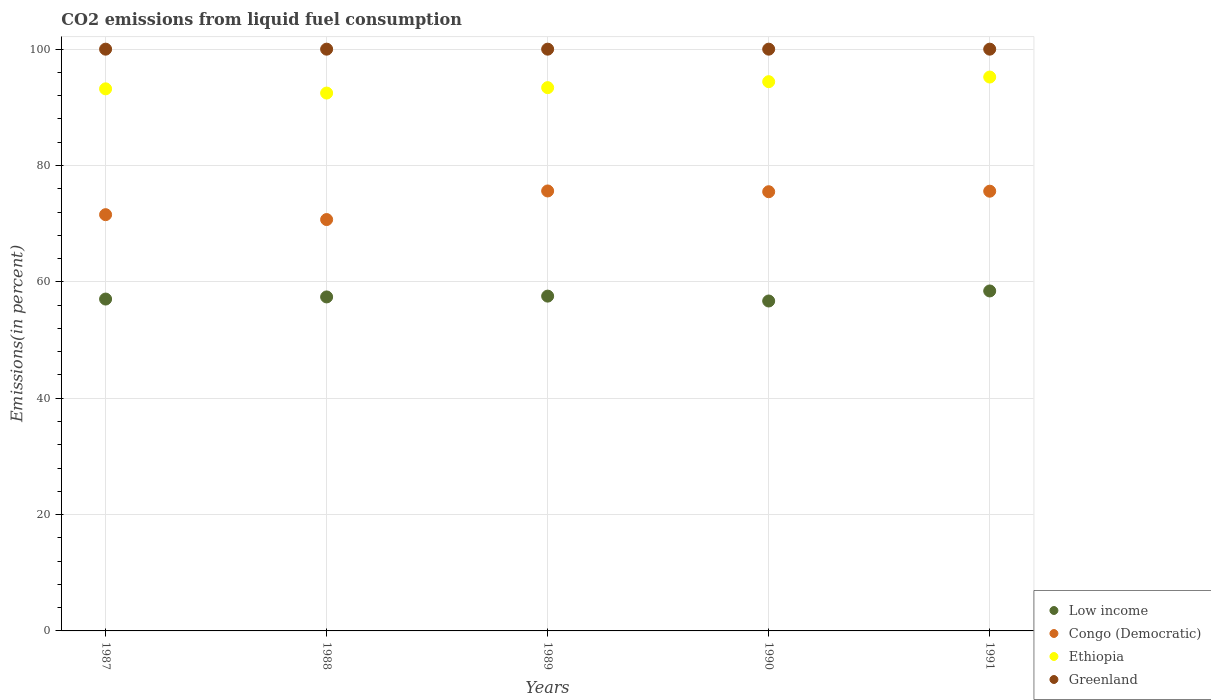What is the total CO2 emitted in Low income in 1990?
Your response must be concise. 56.71. Across all years, what is the maximum total CO2 emitted in Congo (Democratic)?
Ensure brevity in your answer.  75.63. Across all years, what is the minimum total CO2 emitted in Low income?
Your response must be concise. 56.71. In which year was the total CO2 emitted in Greenland maximum?
Ensure brevity in your answer.  1987. What is the total total CO2 emitted in Greenland in the graph?
Provide a succinct answer. 500. What is the difference between the total CO2 emitted in Congo (Democratic) in 1991 and the total CO2 emitted in Low income in 1987?
Your answer should be compact. 18.54. What is the average total CO2 emitted in Congo (Democratic) per year?
Your answer should be compact. 73.79. In the year 1991, what is the difference between the total CO2 emitted in Congo (Democratic) and total CO2 emitted in Greenland?
Provide a succinct answer. -24.41. In how many years, is the total CO2 emitted in Greenland greater than 24 %?
Provide a short and direct response. 5. What is the ratio of the total CO2 emitted in Congo (Democratic) in 1990 to that in 1991?
Keep it short and to the point. 1. What is the difference between the highest and the second highest total CO2 emitted in Low income?
Give a very brief answer. 0.89. What is the difference between the highest and the lowest total CO2 emitted in Low income?
Give a very brief answer. 1.73. In how many years, is the total CO2 emitted in Greenland greater than the average total CO2 emitted in Greenland taken over all years?
Your answer should be very brief. 0. Is it the case that in every year, the sum of the total CO2 emitted in Congo (Democratic) and total CO2 emitted in Ethiopia  is greater than the sum of total CO2 emitted in Low income and total CO2 emitted in Greenland?
Your answer should be compact. No. Is the total CO2 emitted in Greenland strictly greater than the total CO2 emitted in Congo (Democratic) over the years?
Provide a short and direct response. Yes. Is the total CO2 emitted in Congo (Democratic) strictly less than the total CO2 emitted in Ethiopia over the years?
Provide a succinct answer. Yes. How many years are there in the graph?
Offer a very short reply. 5. What is the difference between two consecutive major ticks on the Y-axis?
Make the answer very short. 20. Are the values on the major ticks of Y-axis written in scientific E-notation?
Offer a very short reply. No. Does the graph contain any zero values?
Make the answer very short. No. How many legend labels are there?
Make the answer very short. 4. How are the legend labels stacked?
Make the answer very short. Vertical. What is the title of the graph?
Provide a succinct answer. CO2 emissions from liquid fuel consumption. What is the label or title of the Y-axis?
Offer a very short reply. Emissions(in percent). What is the Emissions(in percent) of Low income in 1987?
Your answer should be very brief. 57.05. What is the Emissions(in percent) of Congo (Democratic) in 1987?
Provide a short and direct response. 71.55. What is the Emissions(in percent) in Ethiopia in 1987?
Offer a terse response. 93.18. What is the Emissions(in percent) in Greenland in 1987?
Give a very brief answer. 100. What is the Emissions(in percent) of Low income in 1988?
Give a very brief answer. 57.41. What is the Emissions(in percent) in Congo (Democratic) in 1988?
Offer a very short reply. 70.71. What is the Emissions(in percent) in Ethiopia in 1988?
Provide a short and direct response. 92.46. What is the Emissions(in percent) of Greenland in 1988?
Make the answer very short. 100. What is the Emissions(in percent) in Low income in 1989?
Offer a very short reply. 57.55. What is the Emissions(in percent) in Congo (Democratic) in 1989?
Your answer should be compact. 75.63. What is the Emissions(in percent) of Ethiopia in 1989?
Keep it short and to the point. 93.39. What is the Emissions(in percent) of Low income in 1990?
Keep it short and to the point. 56.71. What is the Emissions(in percent) in Congo (Democratic) in 1990?
Your answer should be compact. 75.5. What is the Emissions(in percent) in Ethiopia in 1990?
Ensure brevity in your answer.  94.41. What is the Emissions(in percent) of Low income in 1991?
Ensure brevity in your answer.  58.44. What is the Emissions(in percent) in Congo (Democratic) in 1991?
Make the answer very short. 75.59. What is the Emissions(in percent) of Ethiopia in 1991?
Your answer should be very brief. 95.21. Across all years, what is the maximum Emissions(in percent) of Low income?
Provide a succinct answer. 58.44. Across all years, what is the maximum Emissions(in percent) of Congo (Democratic)?
Your response must be concise. 75.63. Across all years, what is the maximum Emissions(in percent) in Ethiopia?
Your answer should be very brief. 95.21. Across all years, what is the minimum Emissions(in percent) in Low income?
Keep it short and to the point. 56.71. Across all years, what is the minimum Emissions(in percent) in Congo (Democratic)?
Your answer should be compact. 70.71. Across all years, what is the minimum Emissions(in percent) of Ethiopia?
Give a very brief answer. 92.46. What is the total Emissions(in percent) of Low income in the graph?
Make the answer very short. 287.16. What is the total Emissions(in percent) in Congo (Democratic) in the graph?
Provide a succinct answer. 368.97. What is the total Emissions(in percent) of Ethiopia in the graph?
Offer a very short reply. 468.64. What is the total Emissions(in percent) of Greenland in the graph?
Give a very brief answer. 500. What is the difference between the Emissions(in percent) of Low income in 1987 and that in 1988?
Provide a short and direct response. -0.37. What is the difference between the Emissions(in percent) of Congo (Democratic) in 1987 and that in 1988?
Offer a very short reply. 0.84. What is the difference between the Emissions(in percent) in Ethiopia in 1987 and that in 1988?
Give a very brief answer. 0.73. What is the difference between the Emissions(in percent) in Greenland in 1987 and that in 1988?
Offer a terse response. 0. What is the difference between the Emissions(in percent) in Low income in 1987 and that in 1989?
Offer a terse response. -0.51. What is the difference between the Emissions(in percent) in Congo (Democratic) in 1987 and that in 1989?
Offer a very short reply. -4.08. What is the difference between the Emissions(in percent) of Ethiopia in 1987 and that in 1989?
Your response must be concise. -0.2. What is the difference between the Emissions(in percent) of Greenland in 1987 and that in 1989?
Provide a succinct answer. 0. What is the difference between the Emissions(in percent) in Low income in 1987 and that in 1990?
Your answer should be very brief. 0.33. What is the difference between the Emissions(in percent) in Congo (Democratic) in 1987 and that in 1990?
Your answer should be compact. -3.94. What is the difference between the Emissions(in percent) of Ethiopia in 1987 and that in 1990?
Give a very brief answer. -1.23. What is the difference between the Emissions(in percent) in Low income in 1987 and that in 1991?
Keep it short and to the point. -1.39. What is the difference between the Emissions(in percent) in Congo (Democratic) in 1987 and that in 1991?
Your answer should be compact. -4.04. What is the difference between the Emissions(in percent) of Ethiopia in 1987 and that in 1991?
Provide a succinct answer. -2.03. What is the difference between the Emissions(in percent) of Greenland in 1987 and that in 1991?
Your answer should be very brief. 0. What is the difference between the Emissions(in percent) of Low income in 1988 and that in 1989?
Your response must be concise. -0.14. What is the difference between the Emissions(in percent) of Congo (Democratic) in 1988 and that in 1989?
Keep it short and to the point. -4.91. What is the difference between the Emissions(in percent) in Ethiopia in 1988 and that in 1989?
Make the answer very short. -0.93. What is the difference between the Emissions(in percent) in Low income in 1988 and that in 1990?
Your answer should be compact. 0.7. What is the difference between the Emissions(in percent) in Congo (Democratic) in 1988 and that in 1990?
Make the answer very short. -4.78. What is the difference between the Emissions(in percent) of Ethiopia in 1988 and that in 1990?
Make the answer very short. -1.96. What is the difference between the Emissions(in percent) of Greenland in 1988 and that in 1990?
Offer a terse response. 0. What is the difference between the Emissions(in percent) in Low income in 1988 and that in 1991?
Your answer should be very brief. -1.03. What is the difference between the Emissions(in percent) of Congo (Democratic) in 1988 and that in 1991?
Your answer should be compact. -4.87. What is the difference between the Emissions(in percent) in Ethiopia in 1988 and that in 1991?
Offer a very short reply. -2.75. What is the difference between the Emissions(in percent) of Greenland in 1988 and that in 1991?
Offer a very short reply. 0. What is the difference between the Emissions(in percent) of Low income in 1989 and that in 1990?
Provide a short and direct response. 0.84. What is the difference between the Emissions(in percent) in Congo (Democratic) in 1989 and that in 1990?
Make the answer very short. 0.13. What is the difference between the Emissions(in percent) of Ethiopia in 1989 and that in 1990?
Your response must be concise. -1.03. What is the difference between the Emissions(in percent) in Greenland in 1989 and that in 1990?
Your response must be concise. 0. What is the difference between the Emissions(in percent) of Low income in 1989 and that in 1991?
Give a very brief answer. -0.89. What is the difference between the Emissions(in percent) in Congo (Democratic) in 1989 and that in 1991?
Your answer should be very brief. 0.04. What is the difference between the Emissions(in percent) in Ethiopia in 1989 and that in 1991?
Offer a very short reply. -1.82. What is the difference between the Emissions(in percent) of Greenland in 1989 and that in 1991?
Your answer should be very brief. 0. What is the difference between the Emissions(in percent) in Low income in 1990 and that in 1991?
Offer a very short reply. -1.73. What is the difference between the Emissions(in percent) in Congo (Democratic) in 1990 and that in 1991?
Your answer should be very brief. -0.09. What is the difference between the Emissions(in percent) in Ethiopia in 1990 and that in 1991?
Make the answer very short. -0.8. What is the difference between the Emissions(in percent) in Greenland in 1990 and that in 1991?
Make the answer very short. 0. What is the difference between the Emissions(in percent) in Low income in 1987 and the Emissions(in percent) in Congo (Democratic) in 1988?
Your answer should be very brief. -13.67. What is the difference between the Emissions(in percent) of Low income in 1987 and the Emissions(in percent) of Ethiopia in 1988?
Your answer should be very brief. -35.41. What is the difference between the Emissions(in percent) of Low income in 1987 and the Emissions(in percent) of Greenland in 1988?
Your answer should be compact. -42.95. What is the difference between the Emissions(in percent) of Congo (Democratic) in 1987 and the Emissions(in percent) of Ethiopia in 1988?
Your answer should be very brief. -20.9. What is the difference between the Emissions(in percent) of Congo (Democratic) in 1987 and the Emissions(in percent) of Greenland in 1988?
Ensure brevity in your answer.  -28.45. What is the difference between the Emissions(in percent) in Ethiopia in 1987 and the Emissions(in percent) in Greenland in 1988?
Offer a very short reply. -6.82. What is the difference between the Emissions(in percent) in Low income in 1987 and the Emissions(in percent) in Congo (Democratic) in 1989?
Keep it short and to the point. -18.58. What is the difference between the Emissions(in percent) in Low income in 1987 and the Emissions(in percent) in Ethiopia in 1989?
Your answer should be compact. -36.34. What is the difference between the Emissions(in percent) of Low income in 1987 and the Emissions(in percent) of Greenland in 1989?
Keep it short and to the point. -42.95. What is the difference between the Emissions(in percent) in Congo (Democratic) in 1987 and the Emissions(in percent) in Ethiopia in 1989?
Keep it short and to the point. -21.83. What is the difference between the Emissions(in percent) in Congo (Democratic) in 1987 and the Emissions(in percent) in Greenland in 1989?
Your response must be concise. -28.45. What is the difference between the Emissions(in percent) in Ethiopia in 1987 and the Emissions(in percent) in Greenland in 1989?
Offer a very short reply. -6.82. What is the difference between the Emissions(in percent) in Low income in 1987 and the Emissions(in percent) in Congo (Democratic) in 1990?
Make the answer very short. -18.45. What is the difference between the Emissions(in percent) of Low income in 1987 and the Emissions(in percent) of Ethiopia in 1990?
Give a very brief answer. -37.37. What is the difference between the Emissions(in percent) of Low income in 1987 and the Emissions(in percent) of Greenland in 1990?
Your response must be concise. -42.95. What is the difference between the Emissions(in percent) of Congo (Democratic) in 1987 and the Emissions(in percent) of Ethiopia in 1990?
Your response must be concise. -22.86. What is the difference between the Emissions(in percent) of Congo (Democratic) in 1987 and the Emissions(in percent) of Greenland in 1990?
Your response must be concise. -28.45. What is the difference between the Emissions(in percent) of Ethiopia in 1987 and the Emissions(in percent) of Greenland in 1990?
Offer a terse response. -6.82. What is the difference between the Emissions(in percent) of Low income in 1987 and the Emissions(in percent) of Congo (Democratic) in 1991?
Keep it short and to the point. -18.54. What is the difference between the Emissions(in percent) of Low income in 1987 and the Emissions(in percent) of Ethiopia in 1991?
Provide a short and direct response. -38.16. What is the difference between the Emissions(in percent) of Low income in 1987 and the Emissions(in percent) of Greenland in 1991?
Offer a terse response. -42.95. What is the difference between the Emissions(in percent) in Congo (Democratic) in 1987 and the Emissions(in percent) in Ethiopia in 1991?
Ensure brevity in your answer.  -23.66. What is the difference between the Emissions(in percent) of Congo (Democratic) in 1987 and the Emissions(in percent) of Greenland in 1991?
Keep it short and to the point. -28.45. What is the difference between the Emissions(in percent) of Ethiopia in 1987 and the Emissions(in percent) of Greenland in 1991?
Offer a terse response. -6.82. What is the difference between the Emissions(in percent) in Low income in 1988 and the Emissions(in percent) in Congo (Democratic) in 1989?
Provide a succinct answer. -18.21. What is the difference between the Emissions(in percent) in Low income in 1988 and the Emissions(in percent) in Ethiopia in 1989?
Provide a succinct answer. -35.97. What is the difference between the Emissions(in percent) in Low income in 1988 and the Emissions(in percent) in Greenland in 1989?
Your response must be concise. -42.59. What is the difference between the Emissions(in percent) in Congo (Democratic) in 1988 and the Emissions(in percent) in Ethiopia in 1989?
Offer a terse response. -22.67. What is the difference between the Emissions(in percent) in Congo (Democratic) in 1988 and the Emissions(in percent) in Greenland in 1989?
Your answer should be compact. -29.29. What is the difference between the Emissions(in percent) in Ethiopia in 1988 and the Emissions(in percent) in Greenland in 1989?
Offer a very short reply. -7.54. What is the difference between the Emissions(in percent) in Low income in 1988 and the Emissions(in percent) in Congo (Democratic) in 1990?
Ensure brevity in your answer.  -18.08. What is the difference between the Emissions(in percent) in Low income in 1988 and the Emissions(in percent) in Ethiopia in 1990?
Keep it short and to the point. -37. What is the difference between the Emissions(in percent) of Low income in 1988 and the Emissions(in percent) of Greenland in 1990?
Offer a terse response. -42.59. What is the difference between the Emissions(in percent) of Congo (Democratic) in 1988 and the Emissions(in percent) of Ethiopia in 1990?
Keep it short and to the point. -23.7. What is the difference between the Emissions(in percent) of Congo (Democratic) in 1988 and the Emissions(in percent) of Greenland in 1990?
Keep it short and to the point. -29.29. What is the difference between the Emissions(in percent) of Ethiopia in 1988 and the Emissions(in percent) of Greenland in 1990?
Give a very brief answer. -7.54. What is the difference between the Emissions(in percent) of Low income in 1988 and the Emissions(in percent) of Congo (Democratic) in 1991?
Your answer should be very brief. -18.17. What is the difference between the Emissions(in percent) in Low income in 1988 and the Emissions(in percent) in Ethiopia in 1991?
Provide a succinct answer. -37.8. What is the difference between the Emissions(in percent) of Low income in 1988 and the Emissions(in percent) of Greenland in 1991?
Offer a very short reply. -42.59. What is the difference between the Emissions(in percent) of Congo (Democratic) in 1988 and the Emissions(in percent) of Ethiopia in 1991?
Keep it short and to the point. -24.5. What is the difference between the Emissions(in percent) of Congo (Democratic) in 1988 and the Emissions(in percent) of Greenland in 1991?
Your answer should be compact. -29.29. What is the difference between the Emissions(in percent) of Ethiopia in 1988 and the Emissions(in percent) of Greenland in 1991?
Provide a succinct answer. -7.54. What is the difference between the Emissions(in percent) in Low income in 1989 and the Emissions(in percent) in Congo (Democratic) in 1990?
Your answer should be compact. -17.94. What is the difference between the Emissions(in percent) of Low income in 1989 and the Emissions(in percent) of Ethiopia in 1990?
Provide a short and direct response. -36.86. What is the difference between the Emissions(in percent) of Low income in 1989 and the Emissions(in percent) of Greenland in 1990?
Keep it short and to the point. -42.45. What is the difference between the Emissions(in percent) of Congo (Democratic) in 1989 and the Emissions(in percent) of Ethiopia in 1990?
Your answer should be very brief. -18.78. What is the difference between the Emissions(in percent) in Congo (Democratic) in 1989 and the Emissions(in percent) in Greenland in 1990?
Your answer should be compact. -24.37. What is the difference between the Emissions(in percent) in Ethiopia in 1989 and the Emissions(in percent) in Greenland in 1990?
Ensure brevity in your answer.  -6.61. What is the difference between the Emissions(in percent) of Low income in 1989 and the Emissions(in percent) of Congo (Democratic) in 1991?
Provide a succinct answer. -18.04. What is the difference between the Emissions(in percent) in Low income in 1989 and the Emissions(in percent) in Ethiopia in 1991?
Make the answer very short. -37.66. What is the difference between the Emissions(in percent) in Low income in 1989 and the Emissions(in percent) in Greenland in 1991?
Make the answer very short. -42.45. What is the difference between the Emissions(in percent) in Congo (Democratic) in 1989 and the Emissions(in percent) in Ethiopia in 1991?
Ensure brevity in your answer.  -19.58. What is the difference between the Emissions(in percent) of Congo (Democratic) in 1989 and the Emissions(in percent) of Greenland in 1991?
Provide a short and direct response. -24.37. What is the difference between the Emissions(in percent) of Ethiopia in 1989 and the Emissions(in percent) of Greenland in 1991?
Provide a short and direct response. -6.61. What is the difference between the Emissions(in percent) in Low income in 1990 and the Emissions(in percent) in Congo (Democratic) in 1991?
Keep it short and to the point. -18.87. What is the difference between the Emissions(in percent) of Low income in 1990 and the Emissions(in percent) of Ethiopia in 1991?
Offer a terse response. -38.5. What is the difference between the Emissions(in percent) in Low income in 1990 and the Emissions(in percent) in Greenland in 1991?
Give a very brief answer. -43.29. What is the difference between the Emissions(in percent) of Congo (Democratic) in 1990 and the Emissions(in percent) of Ethiopia in 1991?
Make the answer very short. -19.71. What is the difference between the Emissions(in percent) in Congo (Democratic) in 1990 and the Emissions(in percent) in Greenland in 1991?
Make the answer very short. -24.5. What is the difference between the Emissions(in percent) in Ethiopia in 1990 and the Emissions(in percent) in Greenland in 1991?
Give a very brief answer. -5.59. What is the average Emissions(in percent) of Low income per year?
Give a very brief answer. 57.43. What is the average Emissions(in percent) of Congo (Democratic) per year?
Offer a terse response. 73.79. What is the average Emissions(in percent) of Ethiopia per year?
Give a very brief answer. 93.73. What is the average Emissions(in percent) in Greenland per year?
Your answer should be very brief. 100. In the year 1987, what is the difference between the Emissions(in percent) of Low income and Emissions(in percent) of Congo (Democratic)?
Provide a short and direct response. -14.51. In the year 1987, what is the difference between the Emissions(in percent) of Low income and Emissions(in percent) of Ethiopia?
Your answer should be compact. -36.14. In the year 1987, what is the difference between the Emissions(in percent) in Low income and Emissions(in percent) in Greenland?
Your answer should be very brief. -42.95. In the year 1987, what is the difference between the Emissions(in percent) of Congo (Democratic) and Emissions(in percent) of Ethiopia?
Keep it short and to the point. -21.63. In the year 1987, what is the difference between the Emissions(in percent) in Congo (Democratic) and Emissions(in percent) in Greenland?
Give a very brief answer. -28.45. In the year 1987, what is the difference between the Emissions(in percent) of Ethiopia and Emissions(in percent) of Greenland?
Your response must be concise. -6.82. In the year 1988, what is the difference between the Emissions(in percent) of Low income and Emissions(in percent) of Ethiopia?
Provide a succinct answer. -35.04. In the year 1988, what is the difference between the Emissions(in percent) of Low income and Emissions(in percent) of Greenland?
Provide a succinct answer. -42.59. In the year 1988, what is the difference between the Emissions(in percent) of Congo (Democratic) and Emissions(in percent) of Ethiopia?
Your answer should be compact. -21.74. In the year 1988, what is the difference between the Emissions(in percent) in Congo (Democratic) and Emissions(in percent) in Greenland?
Offer a terse response. -29.29. In the year 1988, what is the difference between the Emissions(in percent) in Ethiopia and Emissions(in percent) in Greenland?
Keep it short and to the point. -7.54. In the year 1989, what is the difference between the Emissions(in percent) of Low income and Emissions(in percent) of Congo (Democratic)?
Offer a terse response. -18.08. In the year 1989, what is the difference between the Emissions(in percent) of Low income and Emissions(in percent) of Ethiopia?
Offer a terse response. -35.83. In the year 1989, what is the difference between the Emissions(in percent) in Low income and Emissions(in percent) in Greenland?
Your answer should be compact. -42.45. In the year 1989, what is the difference between the Emissions(in percent) in Congo (Democratic) and Emissions(in percent) in Ethiopia?
Provide a short and direct response. -17.76. In the year 1989, what is the difference between the Emissions(in percent) in Congo (Democratic) and Emissions(in percent) in Greenland?
Offer a very short reply. -24.37. In the year 1989, what is the difference between the Emissions(in percent) in Ethiopia and Emissions(in percent) in Greenland?
Ensure brevity in your answer.  -6.61. In the year 1990, what is the difference between the Emissions(in percent) in Low income and Emissions(in percent) in Congo (Democratic)?
Provide a short and direct response. -18.78. In the year 1990, what is the difference between the Emissions(in percent) in Low income and Emissions(in percent) in Ethiopia?
Ensure brevity in your answer.  -37.7. In the year 1990, what is the difference between the Emissions(in percent) of Low income and Emissions(in percent) of Greenland?
Your answer should be compact. -43.29. In the year 1990, what is the difference between the Emissions(in percent) of Congo (Democratic) and Emissions(in percent) of Ethiopia?
Give a very brief answer. -18.92. In the year 1990, what is the difference between the Emissions(in percent) in Congo (Democratic) and Emissions(in percent) in Greenland?
Offer a terse response. -24.5. In the year 1990, what is the difference between the Emissions(in percent) of Ethiopia and Emissions(in percent) of Greenland?
Your response must be concise. -5.59. In the year 1991, what is the difference between the Emissions(in percent) of Low income and Emissions(in percent) of Congo (Democratic)?
Keep it short and to the point. -17.15. In the year 1991, what is the difference between the Emissions(in percent) in Low income and Emissions(in percent) in Ethiopia?
Your answer should be very brief. -36.77. In the year 1991, what is the difference between the Emissions(in percent) of Low income and Emissions(in percent) of Greenland?
Keep it short and to the point. -41.56. In the year 1991, what is the difference between the Emissions(in percent) in Congo (Democratic) and Emissions(in percent) in Ethiopia?
Provide a short and direct response. -19.62. In the year 1991, what is the difference between the Emissions(in percent) of Congo (Democratic) and Emissions(in percent) of Greenland?
Your response must be concise. -24.41. In the year 1991, what is the difference between the Emissions(in percent) in Ethiopia and Emissions(in percent) in Greenland?
Offer a terse response. -4.79. What is the ratio of the Emissions(in percent) of Congo (Democratic) in 1987 to that in 1988?
Keep it short and to the point. 1.01. What is the ratio of the Emissions(in percent) of Ethiopia in 1987 to that in 1988?
Provide a succinct answer. 1.01. What is the ratio of the Emissions(in percent) of Low income in 1987 to that in 1989?
Make the answer very short. 0.99. What is the ratio of the Emissions(in percent) in Congo (Democratic) in 1987 to that in 1989?
Provide a short and direct response. 0.95. What is the ratio of the Emissions(in percent) of Ethiopia in 1987 to that in 1989?
Provide a short and direct response. 1. What is the ratio of the Emissions(in percent) of Low income in 1987 to that in 1990?
Provide a short and direct response. 1.01. What is the ratio of the Emissions(in percent) in Congo (Democratic) in 1987 to that in 1990?
Provide a succinct answer. 0.95. What is the ratio of the Emissions(in percent) in Low income in 1987 to that in 1991?
Your response must be concise. 0.98. What is the ratio of the Emissions(in percent) of Congo (Democratic) in 1987 to that in 1991?
Your answer should be compact. 0.95. What is the ratio of the Emissions(in percent) in Ethiopia in 1987 to that in 1991?
Keep it short and to the point. 0.98. What is the ratio of the Emissions(in percent) of Greenland in 1987 to that in 1991?
Give a very brief answer. 1. What is the ratio of the Emissions(in percent) in Low income in 1988 to that in 1989?
Keep it short and to the point. 1. What is the ratio of the Emissions(in percent) in Congo (Democratic) in 1988 to that in 1989?
Your response must be concise. 0.94. What is the ratio of the Emissions(in percent) of Greenland in 1988 to that in 1989?
Provide a short and direct response. 1. What is the ratio of the Emissions(in percent) of Low income in 1988 to that in 1990?
Make the answer very short. 1.01. What is the ratio of the Emissions(in percent) of Congo (Democratic) in 1988 to that in 1990?
Your answer should be compact. 0.94. What is the ratio of the Emissions(in percent) in Ethiopia in 1988 to that in 1990?
Provide a succinct answer. 0.98. What is the ratio of the Emissions(in percent) of Low income in 1988 to that in 1991?
Make the answer very short. 0.98. What is the ratio of the Emissions(in percent) in Congo (Democratic) in 1988 to that in 1991?
Keep it short and to the point. 0.94. What is the ratio of the Emissions(in percent) in Ethiopia in 1988 to that in 1991?
Offer a very short reply. 0.97. What is the ratio of the Emissions(in percent) of Low income in 1989 to that in 1990?
Ensure brevity in your answer.  1.01. What is the ratio of the Emissions(in percent) of Congo (Democratic) in 1989 to that in 1990?
Your answer should be compact. 1. What is the ratio of the Emissions(in percent) in Ethiopia in 1989 to that in 1990?
Keep it short and to the point. 0.99. What is the ratio of the Emissions(in percent) of Greenland in 1989 to that in 1990?
Provide a short and direct response. 1. What is the ratio of the Emissions(in percent) in Ethiopia in 1989 to that in 1991?
Offer a very short reply. 0.98. What is the ratio of the Emissions(in percent) in Low income in 1990 to that in 1991?
Your answer should be compact. 0.97. What is the difference between the highest and the second highest Emissions(in percent) of Low income?
Your answer should be very brief. 0.89. What is the difference between the highest and the second highest Emissions(in percent) of Congo (Democratic)?
Your answer should be very brief. 0.04. What is the difference between the highest and the second highest Emissions(in percent) in Ethiopia?
Provide a succinct answer. 0.8. What is the difference between the highest and the second highest Emissions(in percent) in Greenland?
Your answer should be compact. 0. What is the difference between the highest and the lowest Emissions(in percent) in Low income?
Keep it short and to the point. 1.73. What is the difference between the highest and the lowest Emissions(in percent) in Congo (Democratic)?
Your answer should be very brief. 4.91. What is the difference between the highest and the lowest Emissions(in percent) of Ethiopia?
Offer a very short reply. 2.75. 